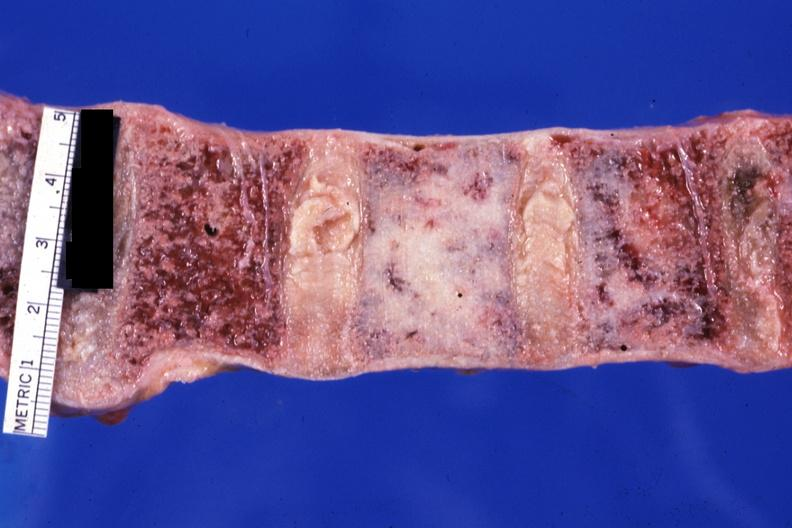s joints present?
Answer the question using a single word or phrase. Yes 